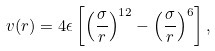<formula> <loc_0><loc_0><loc_500><loc_500>v ( r ) = 4 \epsilon \left [ \left ( \frac { \sigma } { r } \right ) ^ { 1 2 } - \left ( \frac { \sigma } { r } \right ) ^ { 6 } \right ] ,</formula> 